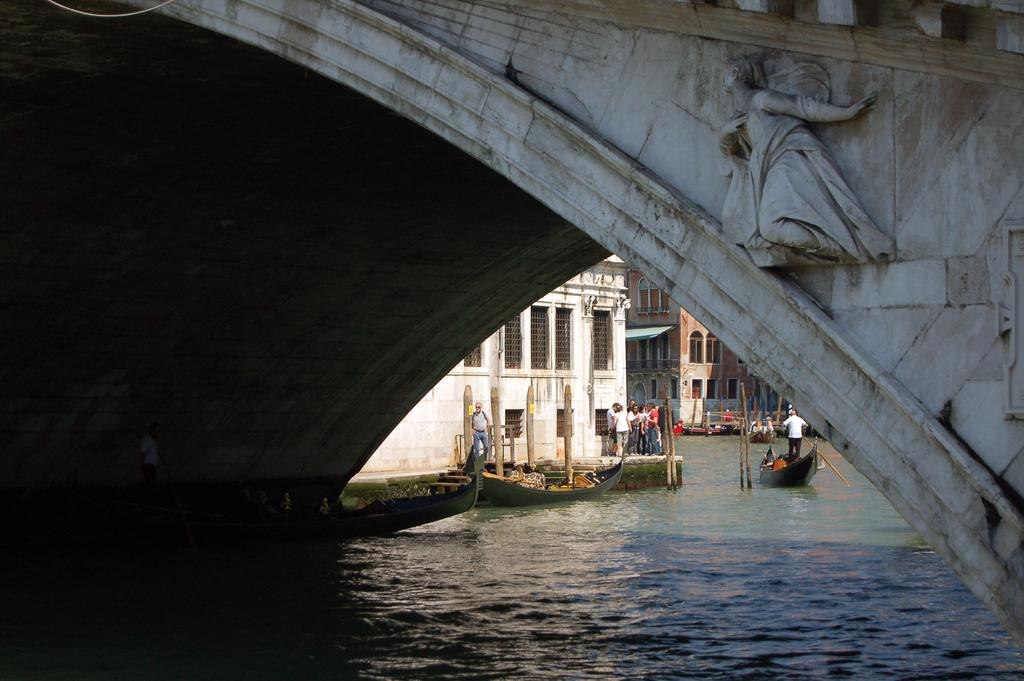What is the main feature of the image? There is a tunnel in the image. What can be seen in the foreground of the image? Water is visible in the image. What artistic element is present in the image? There is a sculpture in the image. What can be seen in the background of the image? There are people, boats, buildings, walls, pillars, and windows in the background of the image. What type of cheese is being used to decorate the doll in the image? There is no cheese or doll present in the image. What star is visible in the sky in the image? The image does not show the sky, so it is not possible to determine if a star is visible. 